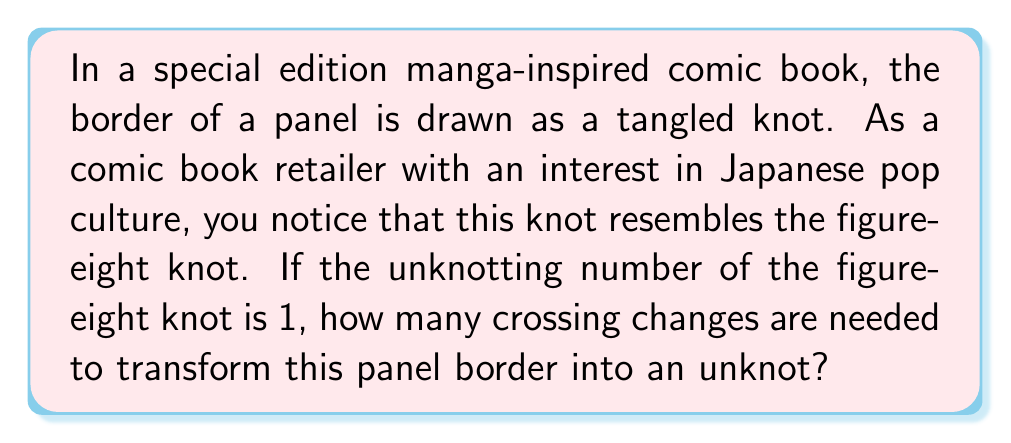Teach me how to tackle this problem. Let's approach this step-by-step:

1. The unknotting number of a knot is the minimum number of crossing changes needed to transform the knot into an unknot (also called the trivial knot).

2. We are given that the panel border resembles the figure-eight knot, which has an unknotting number of 1.

3. The figure-eight knot, also known as the $4_1$ knot in knot theory notation, can be represented as:

   [asy]
   import geometry;

   size(100);
   pen p = black+1;

   path knot = (0,0)..(1,1)..(2,0)..(1,-1)..cycle;
   draw(knot,p);
   draw((1,1)--(1,-1),p);
   draw((0,0)--(2,0),p);
   
   label("1", (0.5,0.5), NW);
   label("2", (1.5,0.5), NE);
   label("3", (1.5,-0.5), SE);
   label("4", (0.5,-0.5), SW);
   [/asy]

4. To unknot the figure-eight knot, we only need to change one crossing. For example, changing the crossing at point 1 or 3 will result in an unknot.

5. Since the panel border resembles the figure-eight knot and the unknotting number is invariant under ambient isotopy (continuous deformations without cutting or gluing), the unknotting number of the panel border will be the same as that of the figure-eight knot.

6. Therefore, only one crossing change is needed to transform the panel border into an unknot.

This concept combines elements of knot theory with the visual aesthetics of manga-style comics, making it relevant to both the mathematical topic and the given persona.
Answer: 1 